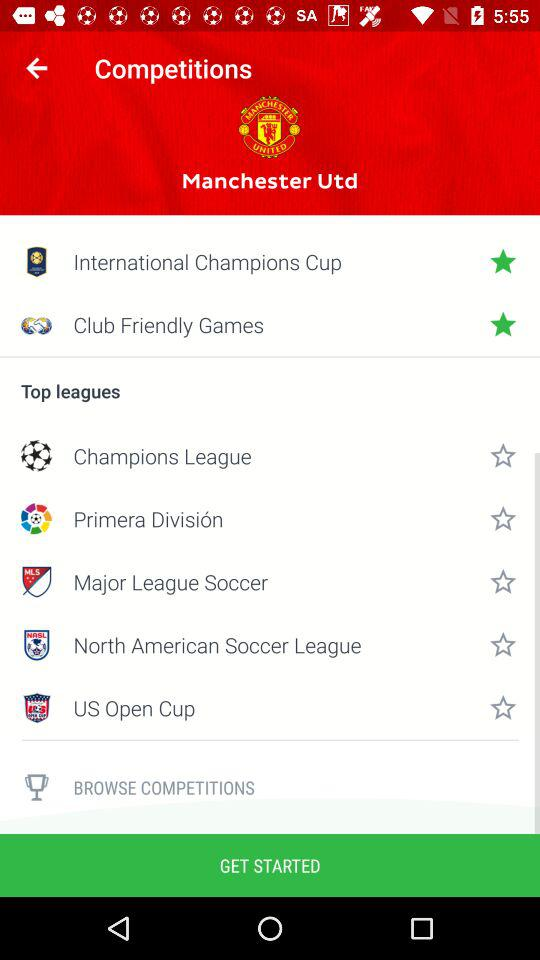What is the application name? The application name is "Manchester Utd". 